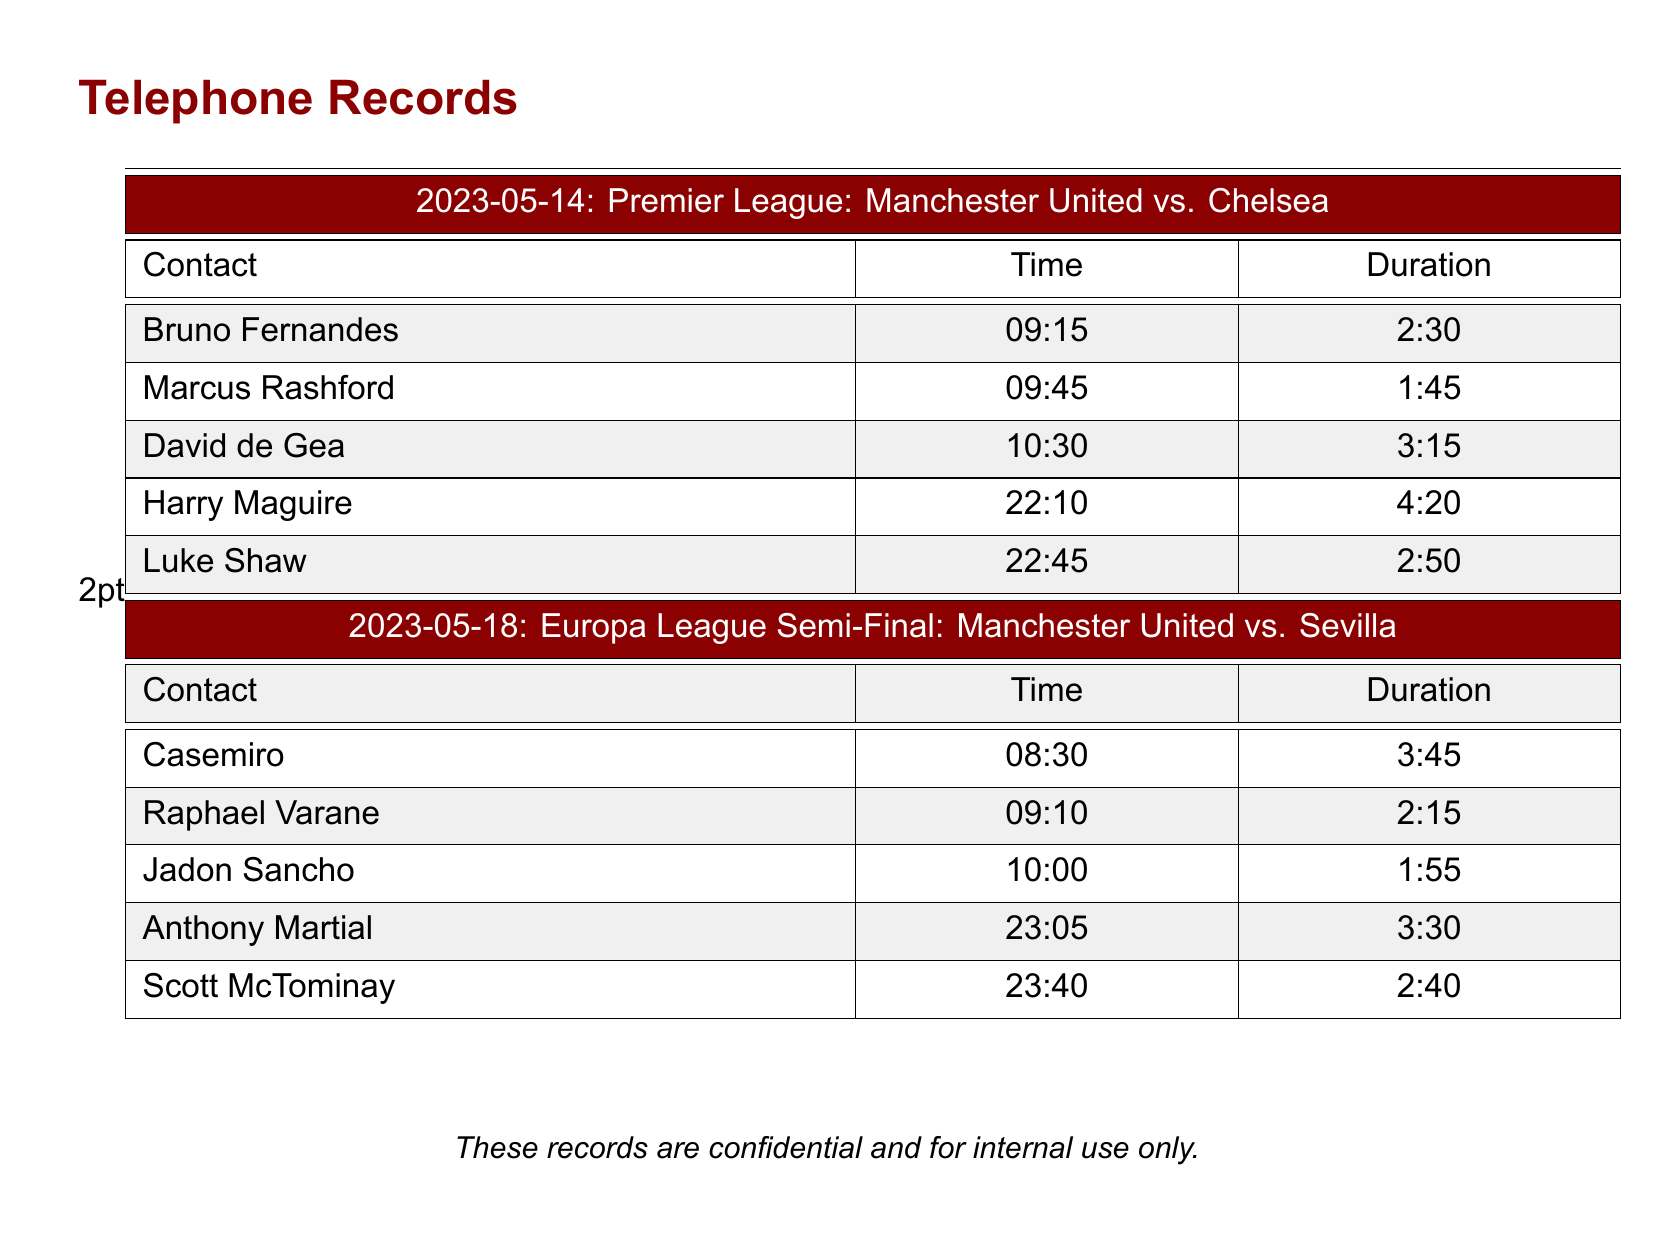What is the date of the first match? The date of the first match is listed at the top of the corresponding section in the document.
Answer: 2023-05-14 Who called Marcus Rashford? The document shows that Marcus Rashford was contacted before the first match.
Answer: Bruno Fernandes What was the duration of the call with David de Gea? The document provides the duration of each call in the corresponding column.
Answer: 3:15 How many calls were made after the Europa League Semi-Final? The document lists all calls made and their timings.
Answer: 2 What time did Anthony Martial receive a call? The time of each call is specified in the document.
Answer: 23:05 Which player had the longest call duration in the records? The longest duration can be found by comparing the durations listed in the document.
Answer: Harry Maguire How many players were contacted for the Premier League match? The number of contacts can be counted from the entries in the relevant section.
Answer: 5 What is the total duration of calls made before the first match? Total duration is calculated by summing the individual durations of all calls prior to the match.
Answer: 14:40 